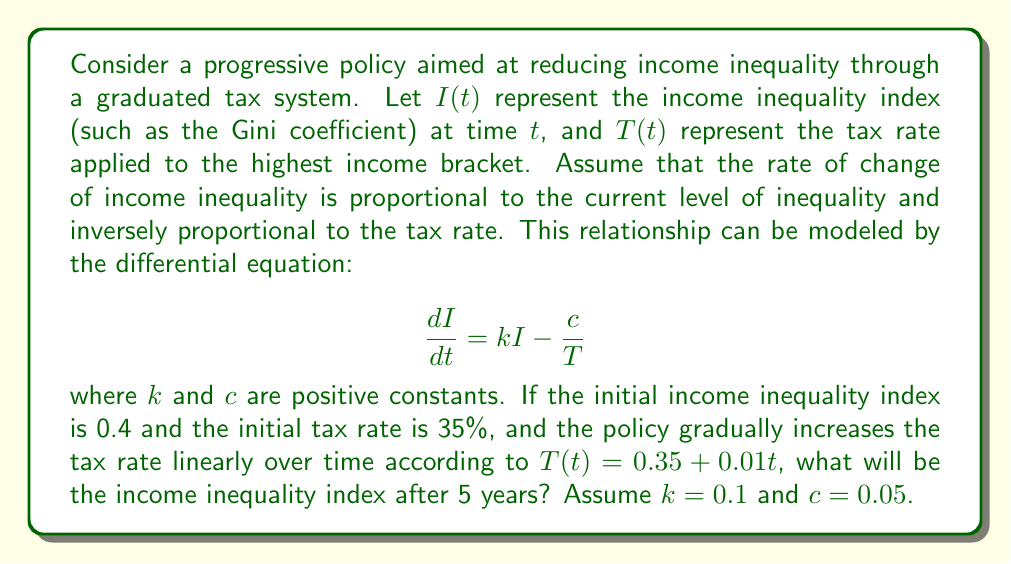Could you help me with this problem? To solve this problem, we need to follow these steps:

1) First, we need to solve the differential equation for $I(t)$. The equation is:

   $$\frac{dI}{dt} = kI - \frac{c}{T}$$

2) Substituting the given function for $T(t)$ and the values of $k$ and $c$:

   $$\frac{dI}{dt} = 0.1I - \frac{0.05}{0.35 + 0.01t}$$

3) This is a non-homogeneous, first-order linear differential equation. It can be solved using an integrating factor method. However, the solution is complex due to the time-dependent denominator.

4) Given the complexity, we can use a numerical method to approximate the solution. Let's use Euler's method with a small step size, say $\Delta t = 0.1$ years.

5) Euler's method states that:

   $$I(t + \Delta t) \approx I(t) + \Delta t \cdot \frac{dI}{dt}$$

6) Starting with $I(0) = 0.4$, we can iteratively calculate $I(t)$ for each time step:

   For $t = 0$ to $5$ years, with step size $0.1$:
   $$I(t + 0.1) = I(t) + 0.1 \cdot (0.1I(t) - \frac{0.05}{0.35 + 0.01t})$$

7) Implementing this in a computational tool (like Python or a spreadsheet) gives us the approximate value of $I(5)$.

8) After 5 years (50 steps of 0.1 years each), we find that $I(5) \approx 0.3798$.
Answer: The income inequality index after 5 years will be approximately 0.3798. 